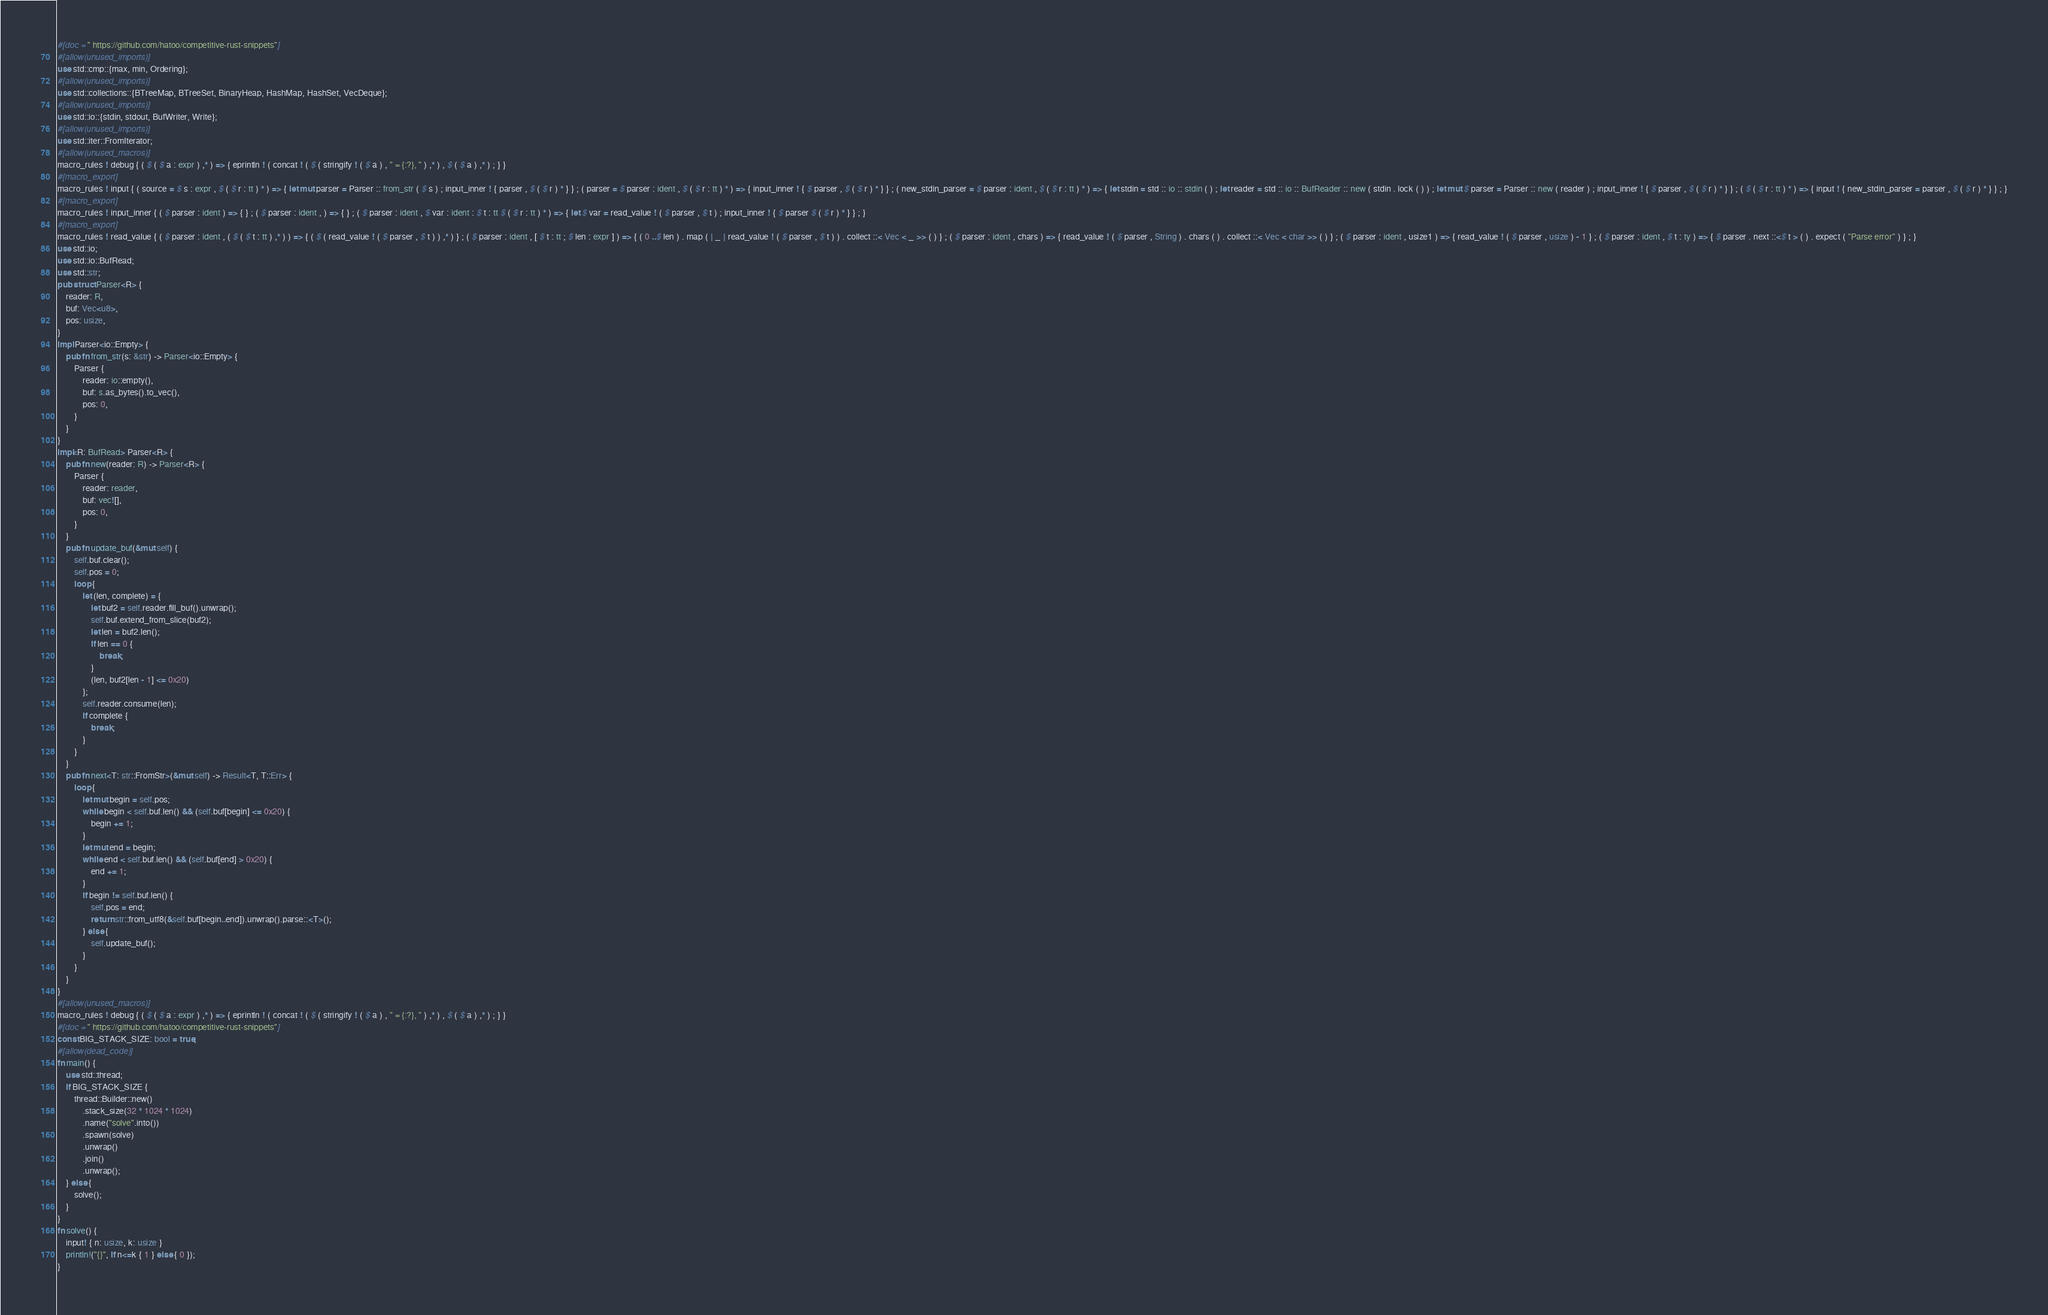<code> <loc_0><loc_0><loc_500><loc_500><_Rust_>#[doc = " https://github.com/hatoo/competitive-rust-snippets"]
#[allow(unused_imports)]
use std::cmp::{max, min, Ordering};
#[allow(unused_imports)]
use std::collections::{BTreeMap, BTreeSet, BinaryHeap, HashMap, HashSet, VecDeque};
#[allow(unused_imports)]
use std::io::{stdin, stdout, BufWriter, Write};
#[allow(unused_imports)]
use std::iter::FromIterator;
#[allow(unused_macros)]
macro_rules ! debug { ( $ ( $ a : expr ) ,* ) => { eprintln ! ( concat ! ( $ ( stringify ! ( $ a ) , " = {:?}, " ) ,* ) , $ ( $ a ) ,* ) ; } }
#[macro_export]
macro_rules ! input { ( source = $ s : expr , $ ( $ r : tt ) * ) => { let mut parser = Parser :: from_str ( $ s ) ; input_inner ! { parser , $ ( $ r ) * } } ; ( parser = $ parser : ident , $ ( $ r : tt ) * ) => { input_inner ! { $ parser , $ ( $ r ) * } } ; ( new_stdin_parser = $ parser : ident , $ ( $ r : tt ) * ) => { let stdin = std :: io :: stdin ( ) ; let reader = std :: io :: BufReader :: new ( stdin . lock ( ) ) ; let mut $ parser = Parser :: new ( reader ) ; input_inner ! { $ parser , $ ( $ r ) * } } ; ( $ ( $ r : tt ) * ) => { input ! { new_stdin_parser = parser , $ ( $ r ) * } } ; }
#[macro_export]
macro_rules ! input_inner { ( $ parser : ident ) => { } ; ( $ parser : ident , ) => { } ; ( $ parser : ident , $ var : ident : $ t : tt $ ( $ r : tt ) * ) => { let $ var = read_value ! ( $ parser , $ t ) ; input_inner ! { $ parser $ ( $ r ) * } } ; }
#[macro_export]
macro_rules ! read_value { ( $ parser : ident , ( $ ( $ t : tt ) ,* ) ) => { ( $ ( read_value ! ( $ parser , $ t ) ) ,* ) } ; ( $ parser : ident , [ $ t : tt ; $ len : expr ] ) => { ( 0 ..$ len ) . map ( | _ | read_value ! ( $ parser , $ t ) ) . collect ::< Vec < _ >> ( ) } ; ( $ parser : ident , chars ) => { read_value ! ( $ parser , String ) . chars ( ) . collect ::< Vec < char >> ( ) } ; ( $ parser : ident , usize1 ) => { read_value ! ( $ parser , usize ) - 1 } ; ( $ parser : ident , $ t : ty ) => { $ parser . next ::<$ t > ( ) . expect ( "Parse error" ) } ; }
use std::io;
use std::io::BufRead;
use std::str;
pub struct Parser<R> {
    reader: R,
    buf: Vec<u8>,
    pos: usize,
}
impl Parser<io::Empty> {
    pub fn from_str(s: &str) -> Parser<io::Empty> {
        Parser {
            reader: io::empty(),
            buf: s.as_bytes().to_vec(),
            pos: 0,
        }
    }
}
impl<R: BufRead> Parser<R> {
    pub fn new(reader: R) -> Parser<R> {
        Parser {
            reader: reader,
            buf: vec![],
            pos: 0,
        }
    }
    pub fn update_buf(&mut self) {
        self.buf.clear();
        self.pos = 0;
        loop {
            let (len, complete) = {
                let buf2 = self.reader.fill_buf().unwrap();
                self.buf.extend_from_slice(buf2);
                let len = buf2.len();
                if len == 0 {
                    break;
                }
                (len, buf2[len - 1] <= 0x20)
            };
            self.reader.consume(len);
            if complete {
                break;
            }
        }
    }
    pub fn next<T: str::FromStr>(&mut self) -> Result<T, T::Err> {
        loop {
            let mut begin = self.pos;
            while begin < self.buf.len() && (self.buf[begin] <= 0x20) {
                begin += 1;
            }
            let mut end = begin;
            while end < self.buf.len() && (self.buf[end] > 0x20) {
                end += 1;
            }
            if begin != self.buf.len() {
                self.pos = end;
                return str::from_utf8(&self.buf[begin..end]).unwrap().parse::<T>();
            } else {
                self.update_buf();
            }
        }
    }
}
#[allow(unused_macros)]
macro_rules ! debug { ( $ ( $ a : expr ) ,* ) => { eprintln ! ( concat ! ( $ ( stringify ! ( $ a ) , " = {:?}, " ) ,* ) , $ ( $ a ) ,* ) ; } }
#[doc = " https://github.com/hatoo/competitive-rust-snippets"]
const BIG_STACK_SIZE: bool = true;
#[allow(dead_code)]
fn main() {
    use std::thread;
    if BIG_STACK_SIZE {
        thread::Builder::new()
            .stack_size(32 * 1024 * 1024)
            .name("solve".into())
            .spawn(solve)
            .unwrap()
            .join()
            .unwrap();
    } else {
        solve();
    }
}
fn solve() {
    input! { n: usize, k: usize }
    println!("{}", if n<=k { 1 } else { 0 });
}
</code> 